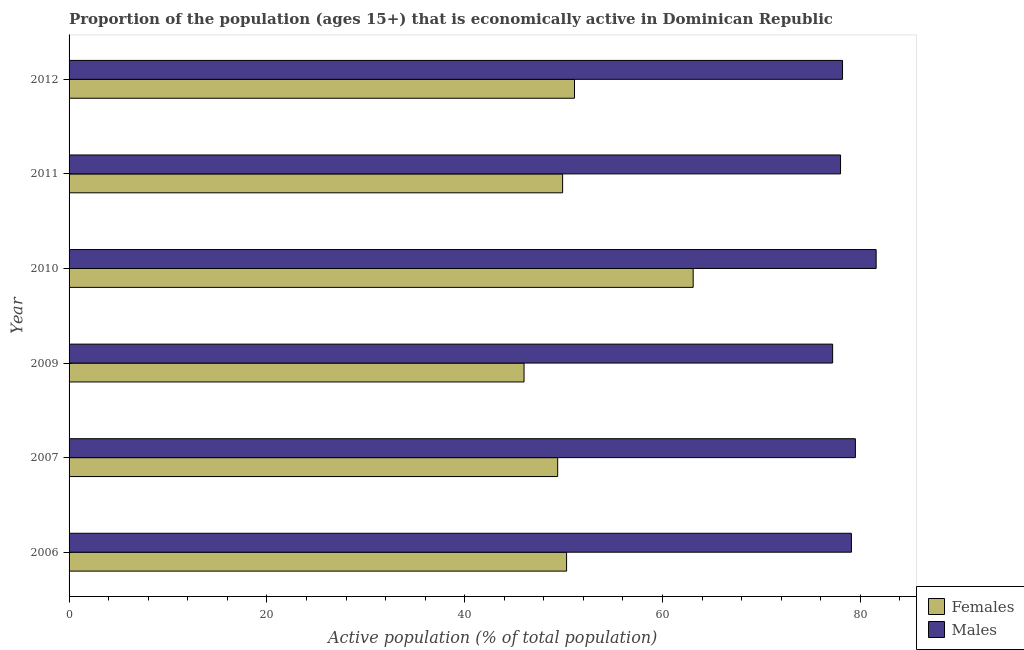How many different coloured bars are there?
Provide a short and direct response. 2. Are the number of bars on each tick of the Y-axis equal?
Make the answer very short. Yes. How many bars are there on the 3rd tick from the bottom?
Your response must be concise. 2. In how many cases, is the number of bars for a given year not equal to the number of legend labels?
Your response must be concise. 0. What is the percentage of economically active female population in 2011?
Provide a succinct answer. 49.9. Across all years, what is the maximum percentage of economically active female population?
Keep it short and to the point. 63.1. Across all years, what is the minimum percentage of economically active female population?
Keep it short and to the point. 46. In which year was the percentage of economically active female population minimum?
Keep it short and to the point. 2009. What is the total percentage of economically active male population in the graph?
Give a very brief answer. 473.6. What is the difference between the percentage of economically active female population in 2007 and that in 2011?
Make the answer very short. -0.5. What is the difference between the percentage of economically active female population in 2010 and the percentage of economically active male population in 2009?
Provide a short and direct response. -14.1. What is the average percentage of economically active female population per year?
Give a very brief answer. 51.63. In the year 2012, what is the difference between the percentage of economically active male population and percentage of economically active female population?
Keep it short and to the point. 27.1. In how many years, is the percentage of economically active female population greater than 72 %?
Make the answer very short. 0. What is the ratio of the percentage of economically active female population in 2009 to that in 2010?
Offer a terse response. 0.73. What is the difference between the highest and the second highest percentage of economically active female population?
Ensure brevity in your answer.  12. Is the sum of the percentage of economically active male population in 2009 and 2010 greater than the maximum percentage of economically active female population across all years?
Make the answer very short. Yes. What does the 1st bar from the top in 2007 represents?
Provide a short and direct response. Males. What does the 2nd bar from the bottom in 2010 represents?
Keep it short and to the point. Males. How many bars are there?
Your response must be concise. 12. Are all the bars in the graph horizontal?
Keep it short and to the point. Yes. Are the values on the major ticks of X-axis written in scientific E-notation?
Your answer should be very brief. No. Does the graph contain grids?
Give a very brief answer. No. Where does the legend appear in the graph?
Give a very brief answer. Bottom right. How many legend labels are there?
Keep it short and to the point. 2. How are the legend labels stacked?
Your answer should be compact. Vertical. What is the title of the graph?
Your response must be concise. Proportion of the population (ages 15+) that is economically active in Dominican Republic. Does "Formally registered" appear as one of the legend labels in the graph?
Provide a short and direct response. No. What is the label or title of the X-axis?
Your response must be concise. Active population (% of total population). What is the label or title of the Y-axis?
Your answer should be compact. Year. What is the Active population (% of total population) of Females in 2006?
Offer a terse response. 50.3. What is the Active population (% of total population) in Males in 2006?
Offer a very short reply. 79.1. What is the Active population (% of total population) in Females in 2007?
Offer a very short reply. 49.4. What is the Active population (% of total population) of Males in 2007?
Keep it short and to the point. 79.5. What is the Active population (% of total population) of Females in 2009?
Ensure brevity in your answer.  46. What is the Active population (% of total population) of Males in 2009?
Offer a terse response. 77.2. What is the Active population (% of total population) of Females in 2010?
Make the answer very short. 63.1. What is the Active population (% of total population) of Males in 2010?
Provide a short and direct response. 81.6. What is the Active population (% of total population) in Females in 2011?
Keep it short and to the point. 49.9. What is the Active population (% of total population) in Females in 2012?
Provide a succinct answer. 51.1. What is the Active population (% of total population) in Males in 2012?
Keep it short and to the point. 78.2. Across all years, what is the maximum Active population (% of total population) of Females?
Your answer should be compact. 63.1. Across all years, what is the maximum Active population (% of total population) of Males?
Provide a succinct answer. 81.6. Across all years, what is the minimum Active population (% of total population) of Females?
Make the answer very short. 46. Across all years, what is the minimum Active population (% of total population) in Males?
Keep it short and to the point. 77.2. What is the total Active population (% of total population) in Females in the graph?
Make the answer very short. 309.8. What is the total Active population (% of total population) in Males in the graph?
Keep it short and to the point. 473.6. What is the difference between the Active population (% of total population) of Males in 2006 and that in 2007?
Offer a terse response. -0.4. What is the difference between the Active population (% of total population) of Males in 2006 and that in 2009?
Give a very brief answer. 1.9. What is the difference between the Active population (% of total population) in Females in 2006 and that in 2010?
Make the answer very short. -12.8. What is the difference between the Active population (% of total population) of Females in 2006 and that in 2011?
Provide a short and direct response. 0.4. What is the difference between the Active population (% of total population) in Males in 2006 and that in 2012?
Give a very brief answer. 0.9. What is the difference between the Active population (% of total population) in Females in 2007 and that in 2009?
Give a very brief answer. 3.4. What is the difference between the Active population (% of total population) in Males in 2007 and that in 2009?
Provide a succinct answer. 2.3. What is the difference between the Active population (% of total population) of Females in 2007 and that in 2010?
Provide a succinct answer. -13.7. What is the difference between the Active population (% of total population) in Females in 2007 and that in 2012?
Keep it short and to the point. -1.7. What is the difference between the Active population (% of total population) of Females in 2009 and that in 2010?
Offer a terse response. -17.1. What is the difference between the Active population (% of total population) of Females in 2009 and that in 2011?
Your answer should be very brief. -3.9. What is the difference between the Active population (% of total population) in Males in 2009 and that in 2011?
Give a very brief answer. -0.8. What is the difference between the Active population (% of total population) of Males in 2009 and that in 2012?
Keep it short and to the point. -1. What is the difference between the Active population (% of total population) of Females in 2010 and that in 2012?
Keep it short and to the point. 12. What is the difference between the Active population (% of total population) of Males in 2010 and that in 2012?
Your response must be concise. 3.4. What is the difference between the Active population (% of total population) of Females in 2011 and that in 2012?
Offer a terse response. -1.2. What is the difference between the Active population (% of total population) of Females in 2006 and the Active population (% of total population) of Males in 2007?
Your answer should be compact. -29.2. What is the difference between the Active population (% of total population) in Females in 2006 and the Active population (% of total population) in Males in 2009?
Give a very brief answer. -26.9. What is the difference between the Active population (% of total population) of Females in 2006 and the Active population (% of total population) of Males in 2010?
Offer a terse response. -31.3. What is the difference between the Active population (% of total population) in Females in 2006 and the Active population (% of total population) in Males in 2011?
Your response must be concise. -27.7. What is the difference between the Active population (% of total population) in Females in 2006 and the Active population (% of total population) in Males in 2012?
Ensure brevity in your answer.  -27.9. What is the difference between the Active population (% of total population) of Females in 2007 and the Active population (% of total population) of Males in 2009?
Your answer should be very brief. -27.8. What is the difference between the Active population (% of total population) of Females in 2007 and the Active population (% of total population) of Males in 2010?
Your answer should be compact. -32.2. What is the difference between the Active population (% of total population) in Females in 2007 and the Active population (% of total population) in Males in 2011?
Make the answer very short. -28.6. What is the difference between the Active population (% of total population) of Females in 2007 and the Active population (% of total population) of Males in 2012?
Provide a short and direct response. -28.8. What is the difference between the Active population (% of total population) of Females in 2009 and the Active population (% of total population) of Males in 2010?
Ensure brevity in your answer.  -35.6. What is the difference between the Active population (% of total population) of Females in 2009 and the Active population (% of total population) of Males in 2011?
Provide a succinct answer. -32. What is the difference between the Active population (% of total population) in Females in 2009 and the Active population (% of total population) in Males in 2012?
Provide a succinct answer. -32.2. What is the difference between the Active population (% of total population) of Females in 2010 and the Active population (% of total population) of Males in 2011?
Provide a succinct answer. -14.9. What is the difference between the Active population (% of total population) of Females in 2010 and the Active population (% of total population) of Males in 2012?
Make the answer very short. -15.1. What is the difference between the Active population (% of total population) of Females in 2011 and the Active population (% of total population) of Males in 2012?
Offer a terse response. -28.3. What is the average Active population (% of total population) of Females per year?
Make the answer very short. 51.63. What is the average Active population (% of total population) in Males per year?
Your response must be concise. 78.93. In the year 2006, what is the difference between the Active population (% of total population) of Females and Active population (% of total population) of Males?
Provide a short and direct response. -28.8. In the year 2007, what is the difference between the Active population (% of total population) in Females and Active population (% of total population) in Males?
Your answer should be very brief. -30.1. In the year 2009, what is the difference between the Active population (% of total population) in Females and Active population (% of total population) in Males?
Keep it short and to the point. -31.2. In the year 2010, what is the difference between the Active population (% of total population) in Females and Active population (% of total population) in Males?
Your answer should be very brief. -18.5. In the year 2011, what is the difference between the Active population (% of total population) of Females and Active population (% of total population) of Males?
Your answer should be very brief. -28.1. In the year 2012, what is the difference between the Active population (% of total population) of Females and Active population (% of total population) of Males?
Ensure brevity in your answer.  -27.1. What is the ratio of the Active population (% of total population) of Females in 2006 to that in 2007?
Give a very brief answer. 1.02. What is the ratio of the Active population (% of total population) of Males in 2006 to that in 2007?
Offer a terse response. 0.99. What is the ratio of the Active population (% of total population) in Females in 2006 to that in 2009?
Offer a terse response. 1.09. What is the ratio of the Active population (% of total population) of Males in 2006 to that in 2009?
Your answer should be compact. 1.02. What is the ratio of the Active population (% of total population) in Females in 2006 to that in 2010?
Keep it short and to the point. 0.8. What is the ratio of the Active population (% of total population) of Males in 2006 to that in 2010?
Your answer should be compact. 0.97. What is the ratio of the Active population (% of total population) of Males in 2006 to that in 2011?
Give a very brief answer. 1.01. What is the ratio of the Active population (% of total population) of Females in 2006 to that in 2012?
Provide a short and direct response. 0.98. What is the ratio of the Active population (% of total population) of Males in 2006 to that in 2012?
Provide a succinct answer. 1.01. What is the ratio of the Active population (% of total population) in Females in 2007 to that in 2009?
Your response must be concise. 1.07. What is the ratio of the Active population (% of total population) of Males in 2007 to that in 2009?
Your response must be concise. 1.03. What is the ratio of the Active population (% of total population) of Females in 2007 to that in 2010?
Give a very brief answer. 0.78. What is the ratio of the Active population (% of total population) in Males in 2007 to that in 2010?
Offer a terse response. 0.97. What is the ratio of the Active population (% of total population) of Males in 2007 to that in 2011?
Offer a very short reply. 1.02. What is the ratio of the Active population (% of total population) of Females in 2007 to that in 2012?
Offer a terse response. 0.97. What is the ratio of the Active population (% of total population) in Males in 2007 to that in 2012?
Provide a short and direct response. 1.02. What is the ratio of the Active population (% of total population) of Females in 2009 to that in 2010?
Your answer should be compact. 0.73. What is the ratio of the Active population (% of total population) in Males in 2009 to that in 2010?
Provide a succinct answer. 0.95. What is the ratio of the Active population (% of total population) of Females in 2009 to that in 2011?
Provide a succinct answer. 0.92. What is the ratio of the Active population (% of total population) in Males in 2009 to that in 2011?
Offer a very short reply. 0.99. What is the ratio of the Active population (% of total population) of Females in 2009 to that in 2012?
Make the answer very short. 0.9. What is the ratio of the Active population (% of total population) of Males in 2009 to that in 2012?
Your answer should be very brief. 0.99. What is the ratio of the Active population (% of total population) of Females in 2010 to that in 2011?
Ensure brevity in your answer.  1.26. What is the ratio of the Active population (% of total population) in Males in 2010 to that in 2011?
Make the answer very short. 1.05. What is the ratio of the Active population (% of total population) in Females in 2010 to that in 2012?
Your answer should be compact. 1.23. What is the ratio of the Active population (% of total population) of Males in 2010 to that in 2012?
Offer a very short reply. 1.04. What is the ratio of the Active population (% of total population) in Females in 2011 to that in 2012?
Keep it short and to the point. 0.98. What is the difference between the highest and the second highest Active population (% of total population) of Males?
Your answer should be very brief. 2.1. What is the difference between the highest and the lowest Active population (% of total population) of Females?
Provide a short and direct response. 17.1. 